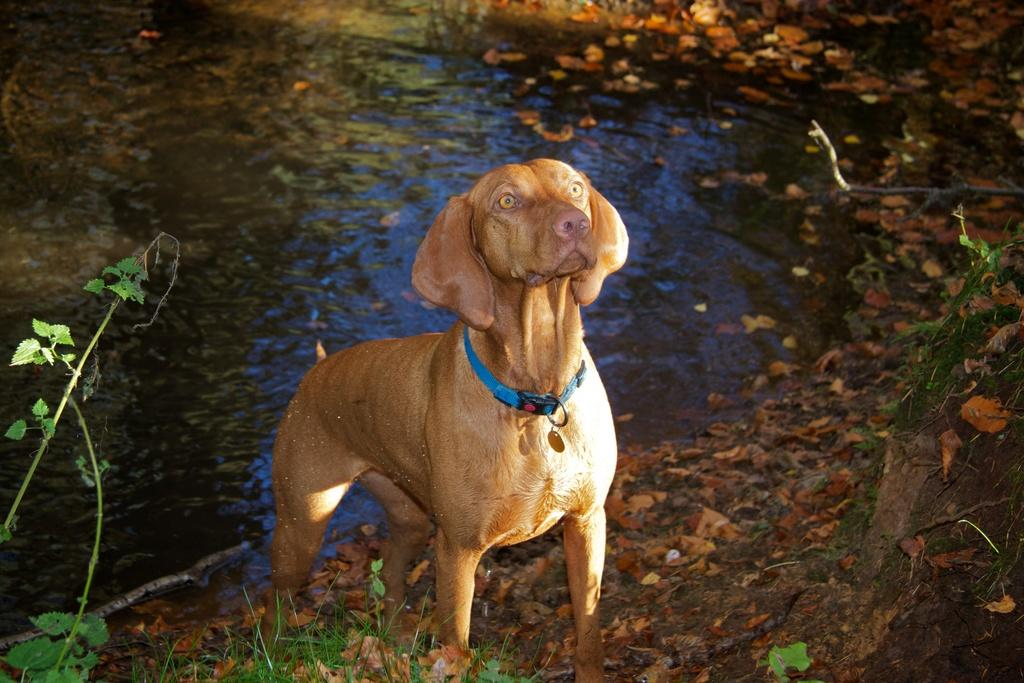What animal is standing in the image? There is a dog standing in the image. What type of vegetation can be seen in the image? Leaves are present in the image. What can be seen in the background of the image? There is water visible in the background of the image. What direction is the tank facing in the image? There is no tank present in the image. 